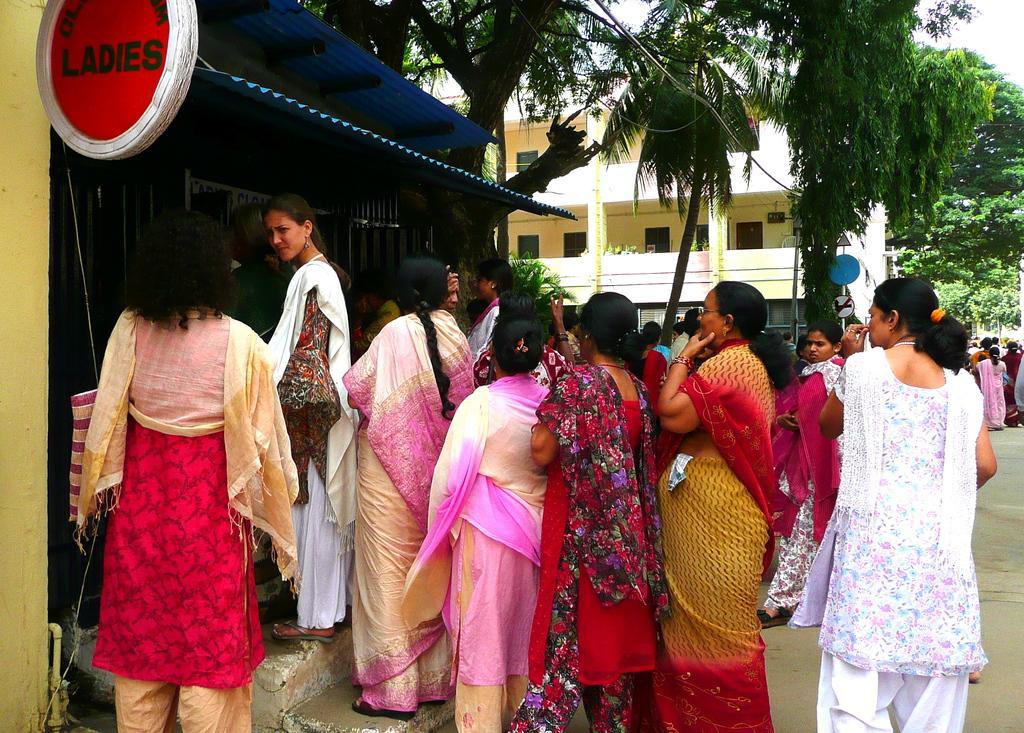How would you summarize this image in a sentence or two? In the image we can see there are people standing and wearing clothes. Here we can see the board and text on the board. Here we can see the road, trees, the building and the sky. 